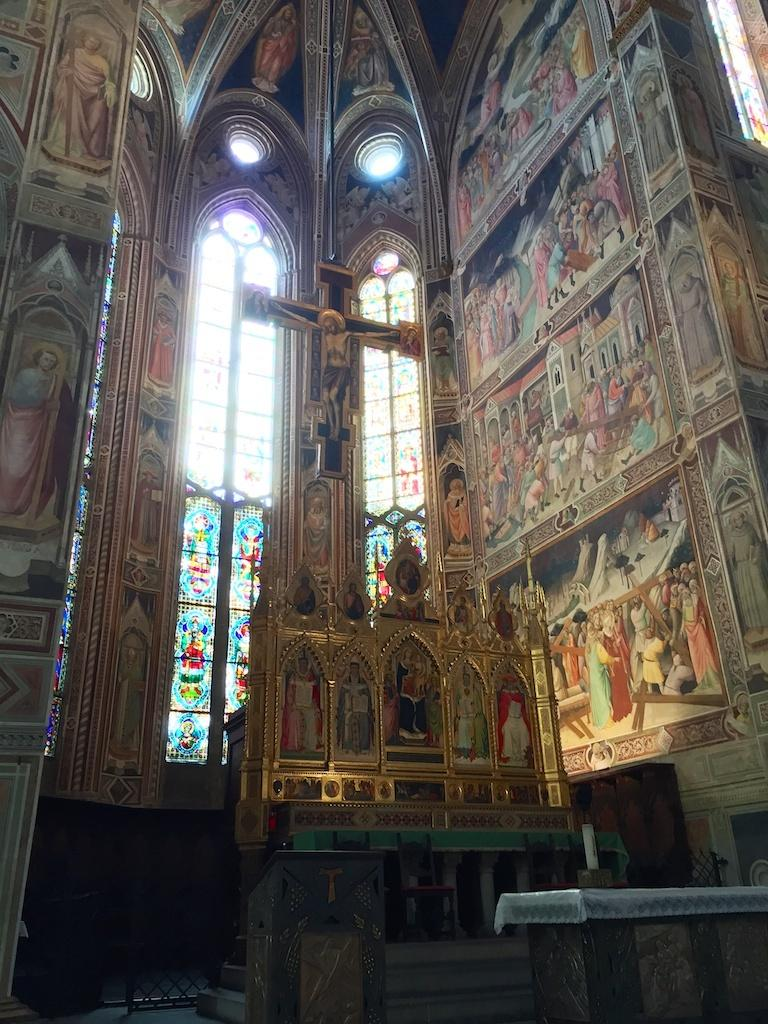What can be seen on the walls in the image? There are pictures on the walls in the image. What allows natural light to enter the room in the image? There are windows in the image. What is unique about the glasses in the image? There are designs on the glasses in the image. What religious symbol is depicted in the image? There is a statue of a person on a cross symbol in the image. What is located on a table at the bottom of the image? There is an object on a table at the bottom of the image. What other objects can be seen in the image? There are other objects visible in the image. How does the star in the image transport people from one place to another? There is no star present in the image, so it cannot transport people. What type of liquid is being poured from the statue in the image? There is no liquid being poured in the image; it features a statue of a person on a cross symbol. 